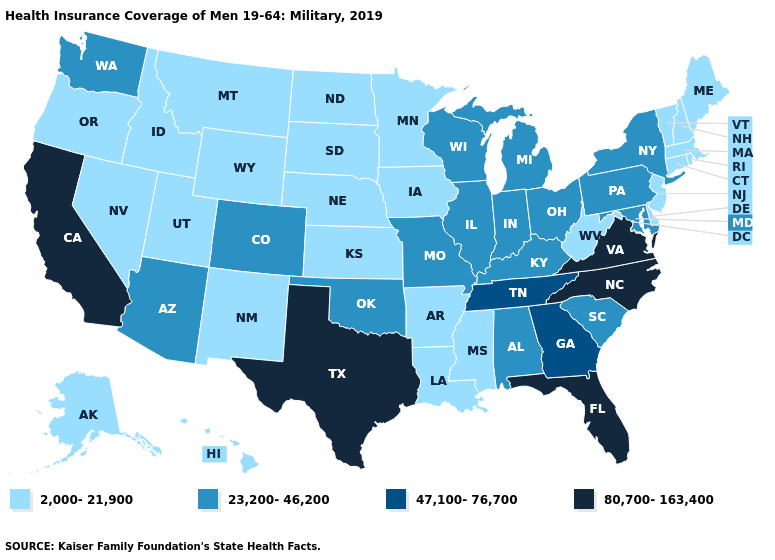Among the states that border Virginia , which have the highest value?
Short answer required. North Carolina. Name the states that have a value in the range 23,200-46,200?
Concise answer only. Alabama, Arizona, Colorado, Illinois, Indiana, Kentucky, Maryland, Michigan, Missouri, New York, Ohio, Oklahoma, Pennsylvania, South Carolina, Washington, Wisconsin. Which states hav the highest value in the South?
Short answer required. Florida, North Carolina, Texas, Virginia. Which states have the highest value in the USA?
Short answer required. California, Florida, North Carolina, Texas, Virginia. Which states have the highest value in the USA?
Answer briefly. California, Florida, North Carolina, Texas, Virginia. Name the states that have a value in the range 47,100-76,700?
Write a very short answer. Georgia, Tennessee. What is the value of Idaho?
Give a very brief answer. 2,000-21,900. What is the highest value in states that border New Jersey?
Quick response, please. 23,200-46,200. What is the highest value in states that border South Dakota?
Quick response, please. 2,000-21,900. What is the highest value in the South ?
Concise answer only. 80,700-163,400. What is the highest value in the USA?
Keep it brief. 80,700-163,400. What is the highest value in the USA?
Give a very brief answer. 80,700-163,400. What is the value of Wyoming?
Short answer required. 2,000-21,900. What is the lowest value in the USA?
Give a very brief answer. 2,000-21,900. Which states have the lowest value in the USA?
Quick response, please. Alaska, Arkansas, Connecticut, Delaware, Hawaii, Idaho, Iowa, Kansas, Louisiana, Maine, Massachusetts, Minnesota, Mississippi, Montana, Nebraska, Nevada, New Hampshire, New Jersey, New Mexico, North Dakota, Oregon, Rhode Island, South Dakota, Utah, Vermont, West Virginia, Wyoming. 